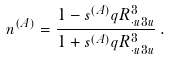Convert formula to latex. <formula><loc_0><loc_0><loc_500><loc_500>n ^ { ( A ) } = \frac { 1 - s ^ { ( A ) } q R ^ { 3 } _ { \cdot u 3 u } } { 1 + s ^ { ( A ) } q R ^ { 3 } _ { \cdot u 3 u } } \, .</formula> 